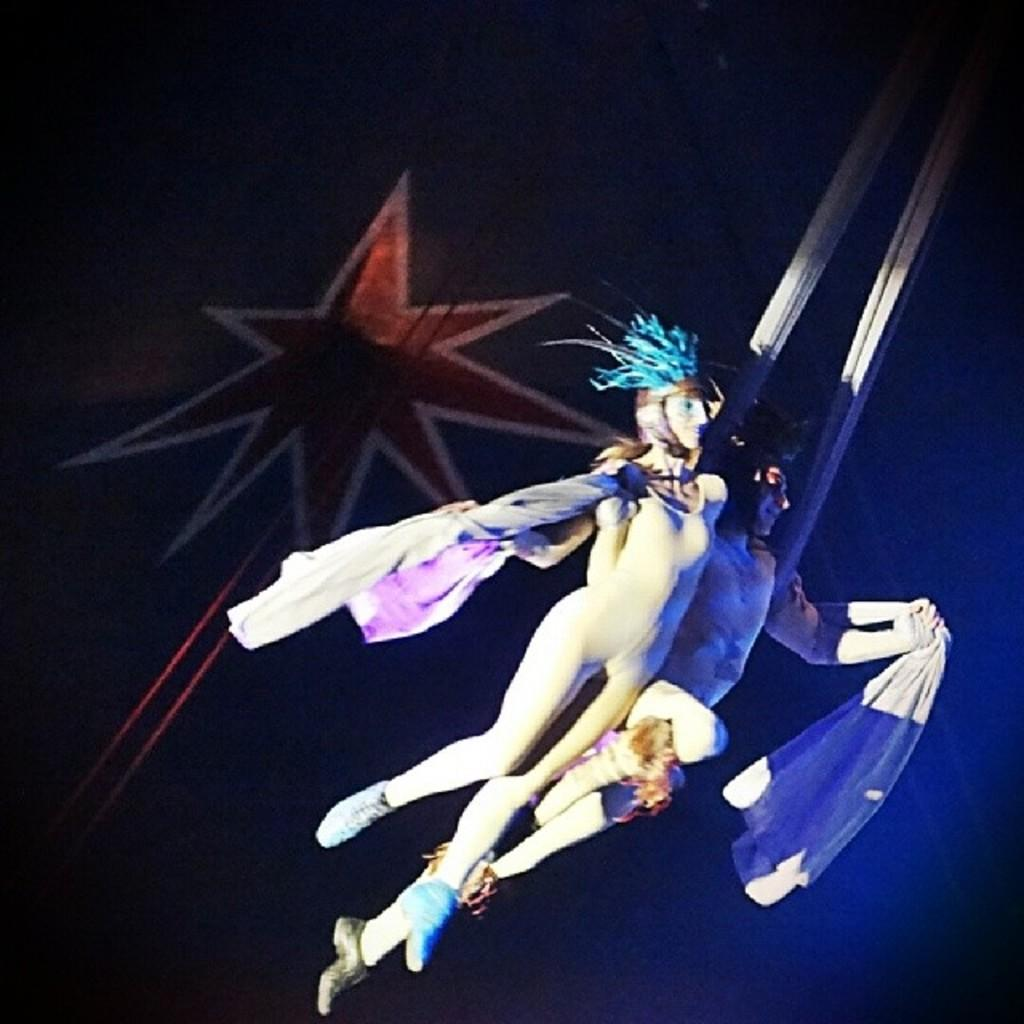How many people are in the image? There are two persons in the image. What are the persons wearing? The persons are wearing costumes. What are the persons holding in their hands? The persons are holding cloth in their hands. What can be seen in the background of the image? There are ropes and a painting on the wall in the background of the image. What type of instrument is the parent playing in the image? There is no parent or instrument present in the image. How many apples are visible on the table in the image? There are no apples visible in the image. 